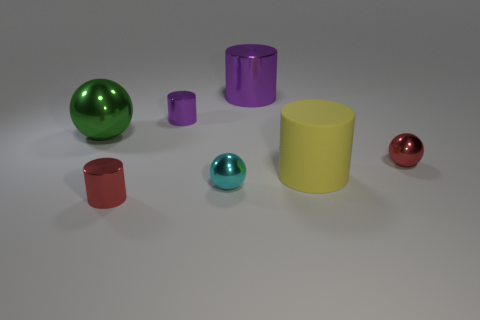What number of other things are the same color as the large metal cylinder?
Offer a terse response. 1. Are there fewer tiny yellow matte balls than tiny cyan objects?
Keep it short and to the point. Yes. How many other things are made of the same material as the green object?
Provide a succinct answer. 5. What size is the yellow matte thing that is the same shape as the big purple shiny object?
Provide a succinct answer. Large. Is the material of the ball right of the yellow rubber cylinder the same as the big yellow cylinder right of the large purple cylinder?
Make the answer very short. No. Is the number of big cylinders in front of the tiny cyan metal sphere less than the number of small red metallic balls?
Keep it short and to the point. Yes. What is the color of the large shiny thing that is the same shape as the rubber object?
Give a very brief answer. Purple. Do the ball in front of the matte thing and the small purple shiny cylinder have the same size?
Provide a succinct answer. Yes. What size is the thing that is left of the metallic cylinder that is in front of the big green metal sphere?
Your answer should be compact. Large. Do the large yellow cylinder and the small cylinder in front of the large green metallic thing have the same material?
Keep it short and to the point. No. 